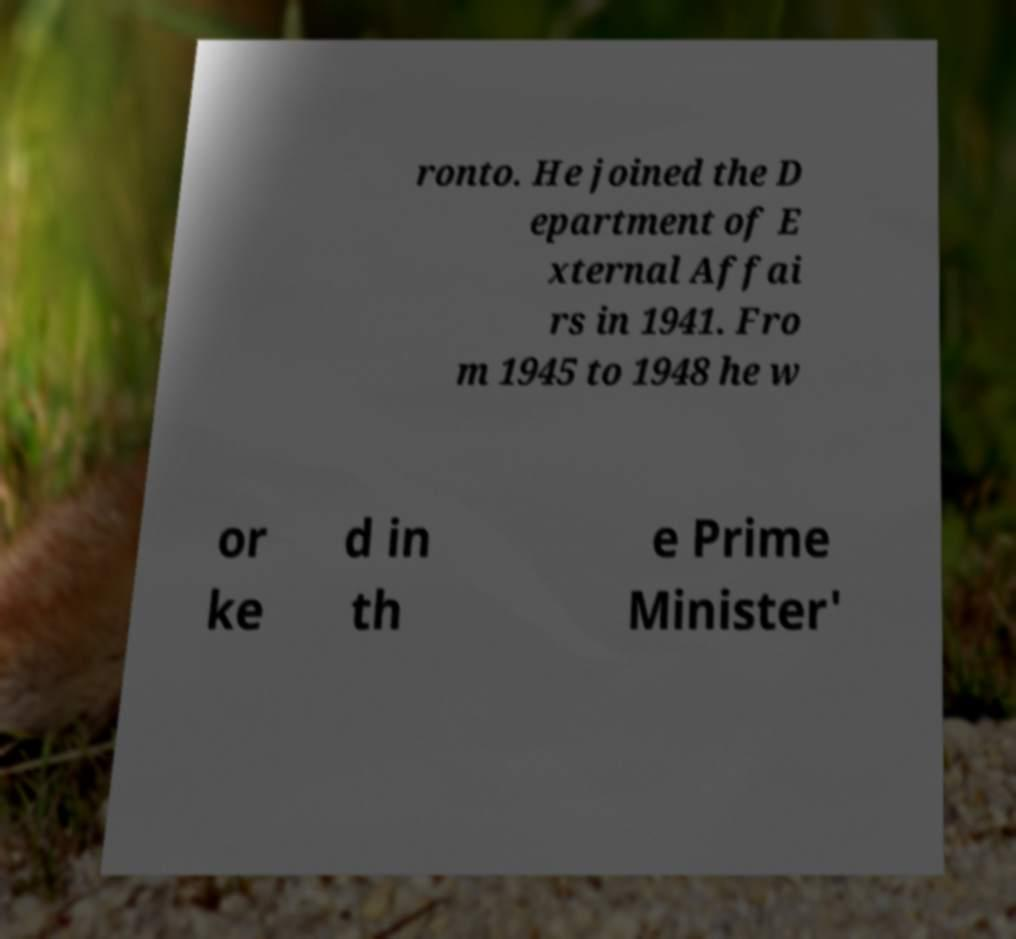For documentation purposes, I need the text within this image transcribed. Could you provide that? ronto. He joined the D epartment of E xternal Affai rs in 1941. Fro m 1945 to 1948 he w or ke d in th e Prime Minister' 